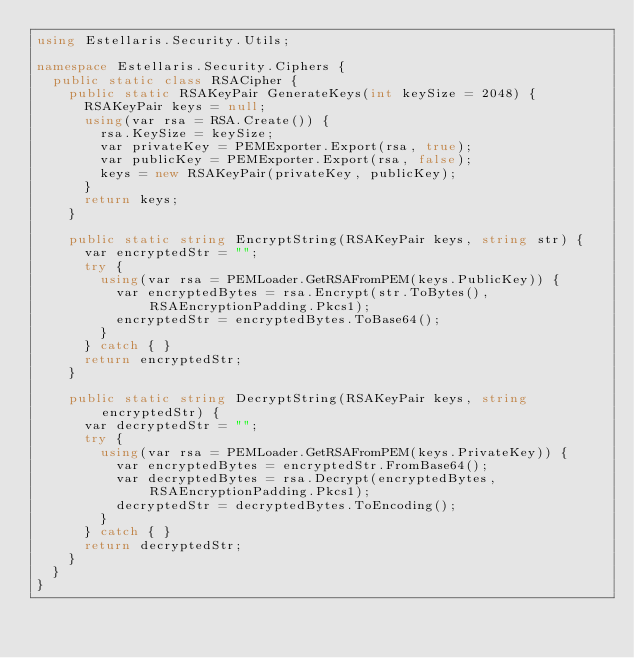<code> <loc_0><loc_0><loc_500><loc_500><_C#_>using Estellaris.Security.Utils;

namespace Estellaris.Security.Ciphers {
  public static class RSACipher {
    public static RSAKeyPair GenerateKeys(int keySize = 2048) {
      RSAKeyPair keys = null;
      using(var rsa = RSA.Create()) {
        rsa.KeySize = keySize;
        var privateKey = PEMExporter.Export(rsa, true);
        var publicKey = PEMExporter.Export(rsa, false);
        keys = new RSAKeyPair(privateKey, publicKey);
      }
      return keys;
    }

    public static string EncryptString(RSAKeyPair keys, string str) {
      var encryptedStr = "";
      try {
        using(var rsa = PEMLoader.GetRSAFromPEM(keys.PublicKey)) {
          var encryptedBytes = rsa.Encrypt(str.ToBytes(), RSAEncryptionPadding.Pkcs1);
          encryptedStr = encryptedBytes.ToBase64();
        }
      } catch { }
      return encryptedStr;
    }

    public static string DecryptString(RSAKeyPair keys, string encryptedStr) {
      var decryptedStr = "";
      try {
        using(var rsa = PEMLoader.GetRSAFromPEM(keys.PrivateKey)) {
          var encryptedBytes = encryptedStr.FromBase64();
          var decryptedBytes = rsa.Decrypt(encryptedBytes, RSAEncryptionPadding.Pkcs1);
          decryptedStr = decryptedBytes.ToEncoding();
        }
      } catch { }
      return decryptedStr;
    }
  }
}</code> 